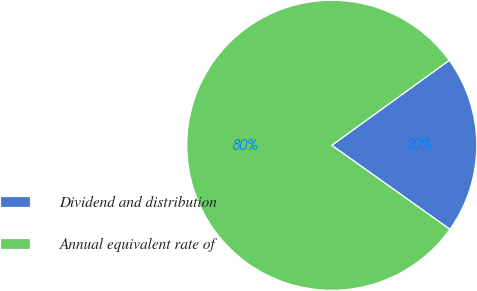<chart> <loc_0><loc_0><loc_500><loc_500><pie_chart><fcel>Dividend and distribution<fcel>Annual equivalent rate of<nl><fcel>19.81%<fcel>80.19%<nl></chart> 